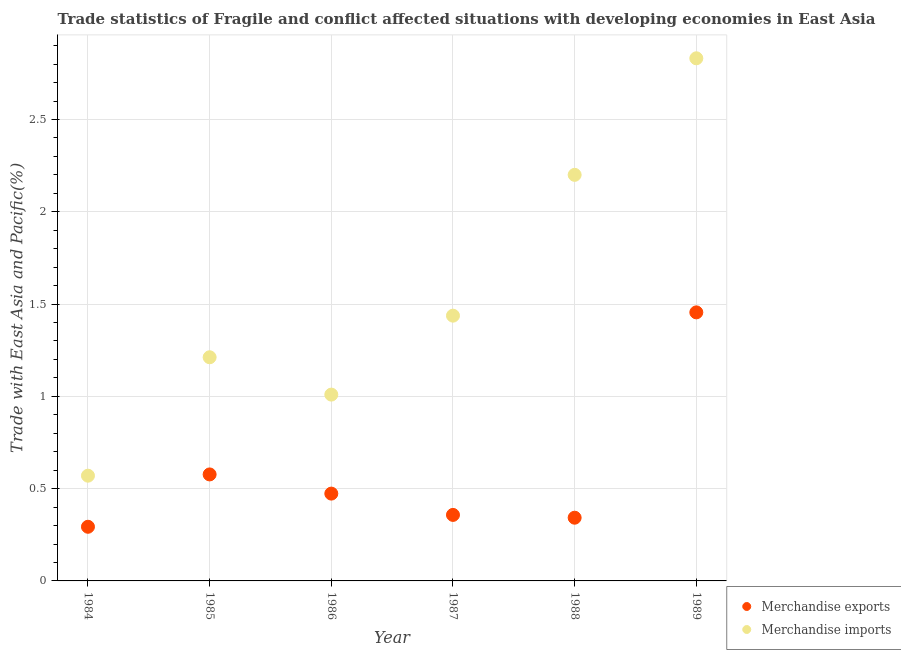Is the number of dotlines equal to the number of legend labels?
Offer a very short reply. Yes. What is the merchandise exports in 1987?
Your response must be concise. 0.36. Across all years, what is the maximum merchandise exports?
Provide a short and direct response. 1.46. Across all years, what is the minimum merchandise imports?
Provide a succinct answer. 0.57. What is the total merchandise exports in the graph?
Your answer should be compact. 3.5. What is the difference between the merchandise imports in 1984 and that in 1988?
Your answer should be compact. -1.63. What is the difference between the merchandise imports in 1988 and the merchandise exports in 1986?
Your answer should be very brief. 1.73. What is the average merchandise exports per year?
Provide a short and direct response. 0.58. In the year 1989, what is the difference between the merchandise exports and merchandise imports?
Provide a succinct answer. -1.38. What is the ratio of the merchandise imports in 1986 to that in 1988?
Give a very brief answer. 0.46. Is the merchandise exports in 1986 less than that in 1989?
Ensure brevity in your answer.  Yes. What is the difference between the highest and the second highest merchandise exports?
Your response must be concise. 0.88. What is the difference between the highest and the lowest merchandise exports?
Your response must be concise. 1.16. In how many years, is the merchandise exports greater than the average merchandise exports taken over all years?
Provide a succinct answer. 1. Is the sum of the merchandise imports in 1986 and 1987 greater than the maximum merchandise exports across all years?
Offer a terse response. Yes. Is the merchandise imports strictly greater than the merchandise exports over the years?
Ensure brevity in your answer.  Yes. Is the merchandise imports strictly less than the merchandise exports over the years?
Make the answer very short. No. How many dotlines are there?
Give a very brief answer. 2. Are the values on the major ticks of Y-axis written in scientific E-notation?
Ensure brevity in your answer.  No. Does the graph contain any zero values?
Provide a short and direct response. No. Where does the legend appear in the graph?
Provide a short and direct response. Bottom right. How many legend labels are there?
Keep it short and to the point. 2. How are the legend labels stacked?
Your response must be concise. Vertical. What is the title of the graph?
Make the answer very short. Trade statistics of Fragile and conflict affected situations with developing economies in East Asia. Does "Death rate" appear as one of the legend labels in the graph?
Give a very brief answer. No. What is the label or title of the Y-axis?
Provide a succinct answer. Trade with East Asia and Pacific(%). What is the Trade with East Asia and Pacific(%) of Merchandise exports in 1984?
Ensure brevity in your answer.  0.29. What is the Trade with East Asia and Pacific(%) of Merchandise imports in 1984?
Keep it short and to the point. 0.57. What is the Trade with East Asia and Pacific(%) of Merchandise exports in 1985?
Offer a very short reply. 0.58. What is the Trade with East Asia and Pacific(%) of Merchandise imports in 1985?
Provide a short and direct response. 1.21. What is the Trade with East Asia and Pacific(%) in Merchandise exports in 1986?
Keep it short and to the point. 0.47. What is the Trade with East Asia and Pacific(%) in Merchandise imports in 1986?
Provide a short and direct response. 1.01. What is the Trade with East Asia and Pacific(%) of Merchandise exports in 1987?
Ensure brevity in your answer.  0.36. What is the Trade with East Asia and Pacific(%) in Merchandise imports in 1987?
Provide a succinct answer. 1.44. What is the Trade with East Asia and Pacific(%) of Merchandise exports in 1988?
Your answer should be very brief. 0.34. What is the Trade with East Asia and Pacific(%) in Merchandise imports in 1988?
Give a very brief answer. 2.2. What is the Trade with East Asia and Pacific(%) of Merchandise exports in 1989?
Offer a terse response. 1.46. What is the Trade with East Asia and Pacific(%) in Merchandise imports in 1989?
Your answer should be very brief. 2.83. Across all years, what is the maximum Trade with East Asia and Pacific(%) of Merchandise exports?
Your answer should be compact. 1.46. Across all years, what is the maximum Trade with East Asia and Pacific(%) of Merchandise imports?
Ensure brevity in your answer.  2.83. Across all years, what is the minimum Trade with East Asia and Pacific(%) in Merchandise exports?
Make the answer very short. 0.29. Across all years, what is the minimum Trade with East Asia and Pacific(%) of Merchandise imports?
Provide a succinct answer. 0.57. What is the total Trade with East Asia and Pacific(%) of Merchandise exports in the graph?
Provide a short and direct response. 3.5. What is the total Trade with East Asia and Pacific(%) of Merchandise imports in the graph?
Offer a terse response. 9.26. What is the difference between the Trade with East Asia and Pacific(%) in Merchandise exports in 1984 and that in 1985?
Provide a succinct answer. -0.28. What is the difference between the Trade with East Asia and Pacific(%) of Merchandise imports in 1984 and that in 1985?
Offer a terse response. -0.64. What is the difference between the Trade with East Asia and Pacific(%) of Merchandise exports in 1984 and that in 1986?
Give a very brief answer. -0.18. What is the difference between the Trade with East Asia and Pacific(%) in Merchandise imports in 1984 and that in 1986?
Make the answer very short. -0.44. What is the difference between the Trade with East Asia and Pacific(%) in Merchandise exports in 1984 and that in 1987?
Make the answer very short. -0.06. What is the difference between the Trade with East Asia and Pacific(%) of Merchandise imports in 1984 and that in 1987?
Your answer should be very brief. -0.87. What is the difference between the Trade with East Asia and Pacific(%) in Merchandise exports in 1984 and that in 1988?
Offer a very short reply. -0.05. What is the difference between the Trade with East Asia and Pacific(%) in Merchandise imports in 1984 and that in 1988?
Provide a short and direct response. -1.63. What is the difference between the Trade with East Asia and Pacific(%) of Merchandise exports in 1984 and that in 1989?
Keep it short and to the point. -1.16. What is the difference between the Trade with East Asia and Pacific(%) of Merchandise imports in 1984 and that in 1989?
Your answer should be compact. -2.26. What is the difference between the Trade with East Asia and Pacific(%) of Merchandise exports in 1985 and that in 1986?
Your answer should be compact. 0.1. What is the difference between the Trade with East Asia and Pacific(%) in Merchandise imports in 1985 and that in 1986?
Provide a short and direct response. 0.2. What is the difference between the Trade with East Asia and Pacific(%) of Merchandise exports in 1985 and that in 1987?
Offer a very short reply. 0.22. What is the difference between the Trade with East Asia and Pacific(%) of Merchandise imports in 1985 and that in 1987?
Provide a succinct answer. -0.23. What is the difference between the Trade with East Asia and Pacific(%) in Merchandise exports in 1985 and that in 1988?
Offer a terse response. 0.23. What is the difference between the Trade with East Asia and Pacific(%) of Merchandise imports in 1985 and that in 1988?
Keep it short and to the point. -0.99. What is the difference between the Trade with East Asia and Pacific(%) in Merchandise exports in 1985 and that in 1989?
Offer a very short reply. -0.88. What is the difference between the Trade with East Asia and Pacific(%) of Merchandise imports in 1985 and that in 1989?
Give a very brief answer. -1.62. What is the difference between the Trade with East Asia and Pacific(%) of Merchandise exports in 1986 and that in 1987?
Offer a very short reply. 0.12. What is the difference between the Trade with East Asia and Pacific(%) in Merchandise imports in 1986 and that in 1987?
Give a very brief answer. -0.43. What is the difference between the Trade with East Asia and Pacific(%) in Merchandise exports in 1986 and that in 1988?
Your answer should be very brief. 0.13. What is the difference between the Trade with East Asia and Pacific(%) in Merchandise imports in 1986 and that in 1988?
Provide a short and direct response. -1.19. What is the difference between the Trade with East Asia and Pacific(%) in Merchandise exports in 1986 and that in 1989?
Keep it short and to the point. -0.98. What is the difference between the Trade with East Asia and Pacific(%) in Merchandise imports in 1986 and that in 1989?
Provide a short and direct response. -1.82. What is the difference between the Trade with East Asia and Pacific(%) of Merchandise exports in 1987 and that in 1988?
Give a very brief answer. 0.02. What is the difference between the Trade with East Asia and Pacific(%) in Merchandise imports in 1987 and that in 1988?
Offer a terse response. -0.76. What is the difference between the Trade with East Asia and Pacific(%) in Merchandise exports in 1987 and that in 1989?
Offer a very short reply. -1.1. What is the difference between the Trade with East Asia and Pacific(%) of Merchandise imports in 1987 and that in 1989?
Your answer should be very brief. -1.39. What is the difference between the Trade with East Asia and Pacific(%) in Merchandise exports in 1988 and that in 1989?
Offer a terse response. -1.11. What is the difference between the Trade with East Asia and Pacific(%) of Merchandise imports in 1988 and that in 1989?
Offer a terse response. -0.63. What is the difference between the Trade with East Asia and Pacific(%) of Merchandise exports in 1984 and the Trade with East Asia and Pacific(%) of Merchandise imports in 1985?
Your answer should be very brief. -0.92. What is the difference between the Trade with East Asia and Pacific(%) of Merchandise exports in 1984 and the Trade with East Asia and Pacific(%) of Merchandise imports in 1986?
Keep it short and to the point. -0.72. What is the difference between the Trade with East Asia and Pacific(%) in Merchandise exports in 1984 and the Trade with East Asia and Pacific(%) in Merchandise imports in 1987?
Your response must be concise. -1.14. What is the difference between the Trade with East Asia and Pacific(%) of Merchandise exports in 1984 and the Trade with East Asia and Pacific(%) of Merchandise imports in 1988?
Ensure brevity in your answer.  -1.91. What is the difference between the Trade with East Asia and Pacific(%) in Merchandise exports in 1984 and the Trade with East Asia and Pacific(%) in Merchandise imports in 1989?
Provide a short and direct response. -2.54. What is the difference between the Trade with East Asia and Pacific(%) in Merchandise exports in 1985 and the Trade with East Asia and Pacific(%) in Merchandise imports in 1986?
Offer a terse response. -0.43. What is the difference between the Trade with East Asia and Pacific(%) in Merchandise exports in 1985 and the Trade with East Asia and Pacific(%) in Merchandise imports in 1987?
Provide a short and direct response. -0.86. What is the difference between the Trade with East Asia and Pacific(%) of Merchandise exports in 1985 and the Trade with East Asia and Pacific(%) of Merchandise imports in 1988?
Provide a short and direct response. -1.62. What is the difference between the Trade with East Asia and Pacific(%) of Merchandise exports in 1985 and the Trade with East Asia and Pacific(%) of Merchandise imports in 1989?
Make the answer very short. -2.25. What is the difference between the Trade with East Asia and Pacific(%) of Merchandise exports in 1986 and the Trade with East Asia and Pacific(%) of Merchandise imports in 1987?
Ensure brevity in your answer.  -0.96. What is the difference between the Trade with East Asia and Pacific(%) of Merchandise exports in 1986 and the Trade with East Asia and Pacific(%) of Merchandise imports in 1988?
Your response must be concise. -1.73. What is the difference between the Trade with East Asia and Pacific(%) in Merchandise exports in 1986 and the Trade with East Asia and Pacific(%) in Merchandise imports in 1989?
Provide a succinct answer. -2.36. What is the difference between the Trade with East Asia and Pacific(%) in Merchandise exports in 1987 and the Trade with East Asia and Pacific(%) in Merchandise imports in 1988?
Offer a terse response. -1.84. What is the difference between the Trade with East Asia and Pacific(%) of Merchandise exports in 1987 and the Trade with East Asia and Pacific(%) of Merchandise imports in 1989?
Offer a very short reply. -2.47. What is the difference between the Trade with East Asia and Pacific(%) in Merchandise exports in 1988 and the Trade with East Asia and Pacific(%) in Merchandise imports in 1989?
Ensure brevity in your answer.  -2.49. What is the average Trade with East Asia and Pacific(%) in Merchandise exports per year?
Offer a terse response. 0.58. What is the average Trade with East Asia and Pacific(%) in Merchandise imports per year?
Provide a short and direct response. 1.54. In the year 1984, what is the difference between the Trade with East Asia and Pacific(%) in Merchandise exports and Trade with East Asia and Pacific(%) in Merchandise imports?
Provide a short and direct response. -0.28. In the year 1985, what is the difference between the Trade with East Asia and Pacific(%) in Merchandise exports and Trade with East Asia and Pacific(%) in Merchandise imports?
Give a very brief answer. -0.63. In the year 1986, what is the difference between the Trade with East Asia and Pacific(%) of Merchandise exports and Trade with East Asia and Pacific(%) of Merchandise imports?
Offer a terse response. -0.54. In the year 1987, what is the difference between the Trade with East Asia and Pacific(%) in Merchandise exports and Trade with East Asia and Pacific(%) in Merchandise imports?
Offer a terse response. -1.08. In the year 1988, what is the difference between the Trade with East Asia and Pacific(%) in Merchandise exports and Trade with East Asia and Pacific(%) in Merchandise imports?
Offer a terse response. -1.86. In the year 1989, what is the difference between the Trade with East Asia and Pacific(%) of Merchandise exports and Trade with East Asia and Pacific(%) of Merchandise imports?
Your answer should be compact. -1.38. What is the ratio of the Trade with East Asia and Pacific(%) of Merchandise exports in 1984 to that in 1985?
Offer a very short reply. 0.51. What is the ratio of the Trade with East Asia and Pacific(%) in Merchandise imports in 1984 to that in 1985?
Ensure brevity in your answer.  0.47. What is the ratio of the Trade with East Asia and Pacific(%) of Merchandise exports in 1984 to that in 1986?
Offer a terse response. 0.62. What is the ratio of the Trade with East Asia and Pacific(%) of Merchandise imports in 1984 to that in 1986?
Provide a short and direct response. 0.56. What is the ratio of the Trade with East Asia and Pacific(%) of Merchandise exports in 1984 to that in 1987?
Ensure brevity in your answer.  0.82. What is the ratio of the Trade with East Asia and Pacific(%) of Merchandise imports in 1984 to that in 1987?
Make the answer very short. 0.4. What is the ratio of the Trade with East Asia and Pacific(%) in Merchandise exports in 1984 to that in 1988?
Offer a very short reply. 0.86. What is the ratio of the Trade with East Asia and Pacific(%) of Merchandise imports in 1984 to that in 1988?
Your answer should be compact. 0.26. What is the ratio of the Trade with East Asia and Pacific(%) of Merchandise exports in 1984 to that in 1989?
Keep it short and to the point. 0.2. What is the ratio of the Trade with East Asia and Pacific(%) of Merchandise imports in 1984 to that in 1989?
Give a very brief answer. 0.2. What is the ratio of the Trade with East Asia and Pacific(%) of Merchandise exports in 1985 to that in 1986?
Provide a short and direct response. 1.22. What is the ratio of the Trade with East Asia and Pacific(%) in Merchandise imports in 1985 to that in 1986?
Your answer should be compact. 1.2. What is the ratio of the Trade with East Asia and Pacific(%) of Merchandise exports in 1985 to that in 1987?
Give a very brief answer. 1.61. What is the ratio of the Trade with East Asia and Pacific(%) in Merchandise imports in 1985 to that in 1987?
Your answer should be very brief. 0.84. What is the ratio of the Trade with East Asia and Pacific(%) in Merchandise exports in 1985 to that in 1988?
Your answer should be very brief. 1.68. What is the ratio of the Trade with East Asia and Pacific(%) of Merchandise imports in 1985 to that in 1988?
Provide a succinct answer. 0.55. What is the ratio of the Trade with East Asia and Pacific(%) of Merchandise exports in 1985 to that in 1989?
Your response must be concise. 0.4. What is the ratio of the Trade with East Asia and Pacific(%) of Merchandise imports in 1985 to that in 1989?
Provide a short and direct response. 0.43. What is the ratio of the Trade with East Asia and Pacific(%) in Merchandise exports in 1986 to that in 1987?
Offer a terse response. 1.32. What is the ratio of the Trade with East Asia and Pacific(%) of Merchandise imports in 1986 to that in 1987?
Make the answer very short. 0.7. What is the ratio of the Trade with East Asia and Pacific(%) in Merchandise exports in 1986 to that in 1988?
Provide a succinct answer. 1.38. What is the ratio of the Trade with East Asia and Pacific(%) in Merchandise imports in 1986 to that in 1988?
Your answer should be very brief. 0.46. What is the ratio of the Trade with East Asia and Pacific(%) of Merchandise exports in 1986 to that in 1989?
Ensure brevity in your answer.  0.33. What is the ratio of the Trade with East Asia and Pacific(%) in Merchandise imports in 1986 to that in 1989?
Your answer should be very brief. 0.36. What is the ratio of the Trade with East Asia and Pacific(%) in Merchandise exports in 1987 to that in 1988?
Your answer should be compact. 1.04. What is the ratio of the Trade with East Asia and Pacific(%) in Merchandise imports in 1987 to that in 1988?
Provide a succinct answer. 0.65. What is the ratio of the Trade with East Asia and Pacific(%) of Merchandise exports in 1987 to that in 1989?
Provide a short and direct response. 0.25. What is the ratio of the Trade with East Asia and Pacific(%) in Merchandise imports in 1987 to that in 1989?
Your response must be concise. 0.51. What is the ratio of the Trade with East Asia and Pacific(%) in Merchandise exports in 1988 to that in 1989?
Your response must be concise. 0.24. What is the ratio of the Trade with East Asia and Pacific(%) of Merchandise imports in 1988 to that in 1989?
Offer a terse response. 0.78. What is the difference between the highest and the second highest Trade with East Asia and Pacific(%) in Merchandise exports?
Ensure brevity in your answer.  0.88. What is the difference between the highest and the second highest Trade with East Asia and Pacific(%) of Merchandise imports?
Provide a short and direct response. 0.63. What is the difference between the highest and the lowest Trade with East Asia and Pacific(%) of Merchandise exports?
Offer a terse response. 1.16. What is the difference between the highest and the lowest Trade with East Asia and Pacific(%) of Merchandise imports?
Offer a terse response. 2.26. 